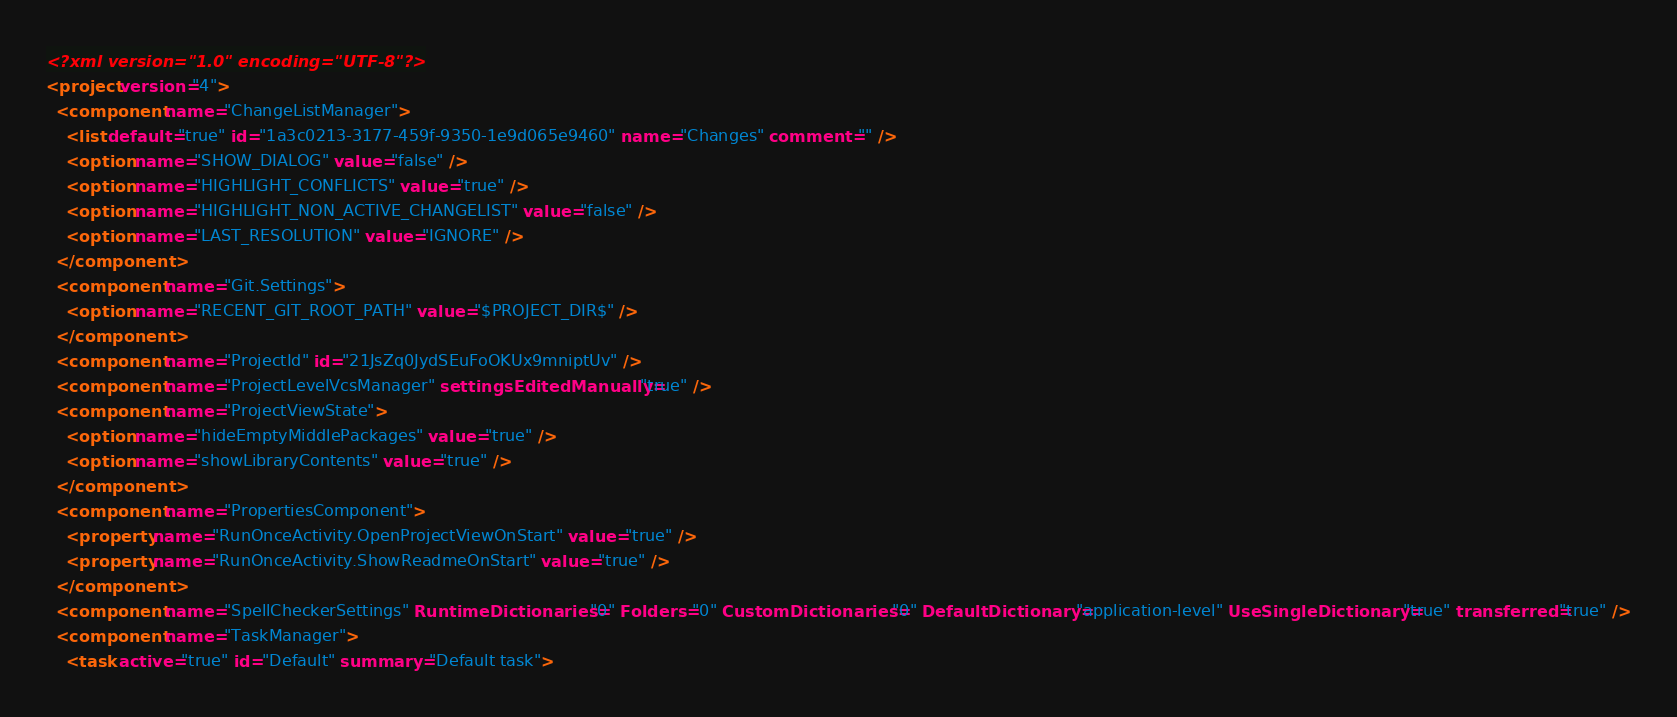<code> <loc_0><loc_0><loc_500><loc_500><_XML_><?xml version="1.0" encoding="UTF-8"?>
<project version="4">
  <component name="ChangeListManager">
    <list default="true" id="1a3c0213-3177-459f-9350-1e9d065e9460" name="Changes" comment="" />
    <option name="SHOW_DIALOG" value="false" />
    <option name="HIGHLIGHT_CONFLICTS" value="true" />
    <option name="HIGHLIGHT_NON_ACTIVE_CHANGELIST" value="false" />
    <option name="LAST_RESOLUTION" value="IGNORE" />
  </component>
  <component name="Git.Settings">
    <option name="RECENT_GIT_ROOT_PATH" value="$PROJECT_DIR$" />
  </component>
  <component name="ProjectId" id="21JsZq0JydSEuFoOKUx9mniptUv" />
  <component name="ProjectLevelVcsManager" settingsEditedManually="true" />
  <component name="ProjectViewState">
    <option name="hideEmptyMiddlePackages" value="true" />
    <option name="showLibraryContents" value="true" />
  </component>
  <component name="PropertiesComponent">
    <property name="RunOnceActivity.OpenProjectViewOnStart" value="true" />
    <property name="RunOnceActivity.ShowReadmeOnStart" value="true" />
  </component>
  <component name="SpellCheckerSettings" RuntimeDictionaries="0" Folders="0" CustomDictionaries="0" DefaultDictionary="application-level" UseSingleDictionary="true" transferred="true" />
  <component name="TaskManager">
    <task active="true" id="Default" summary="Default task"></code> 